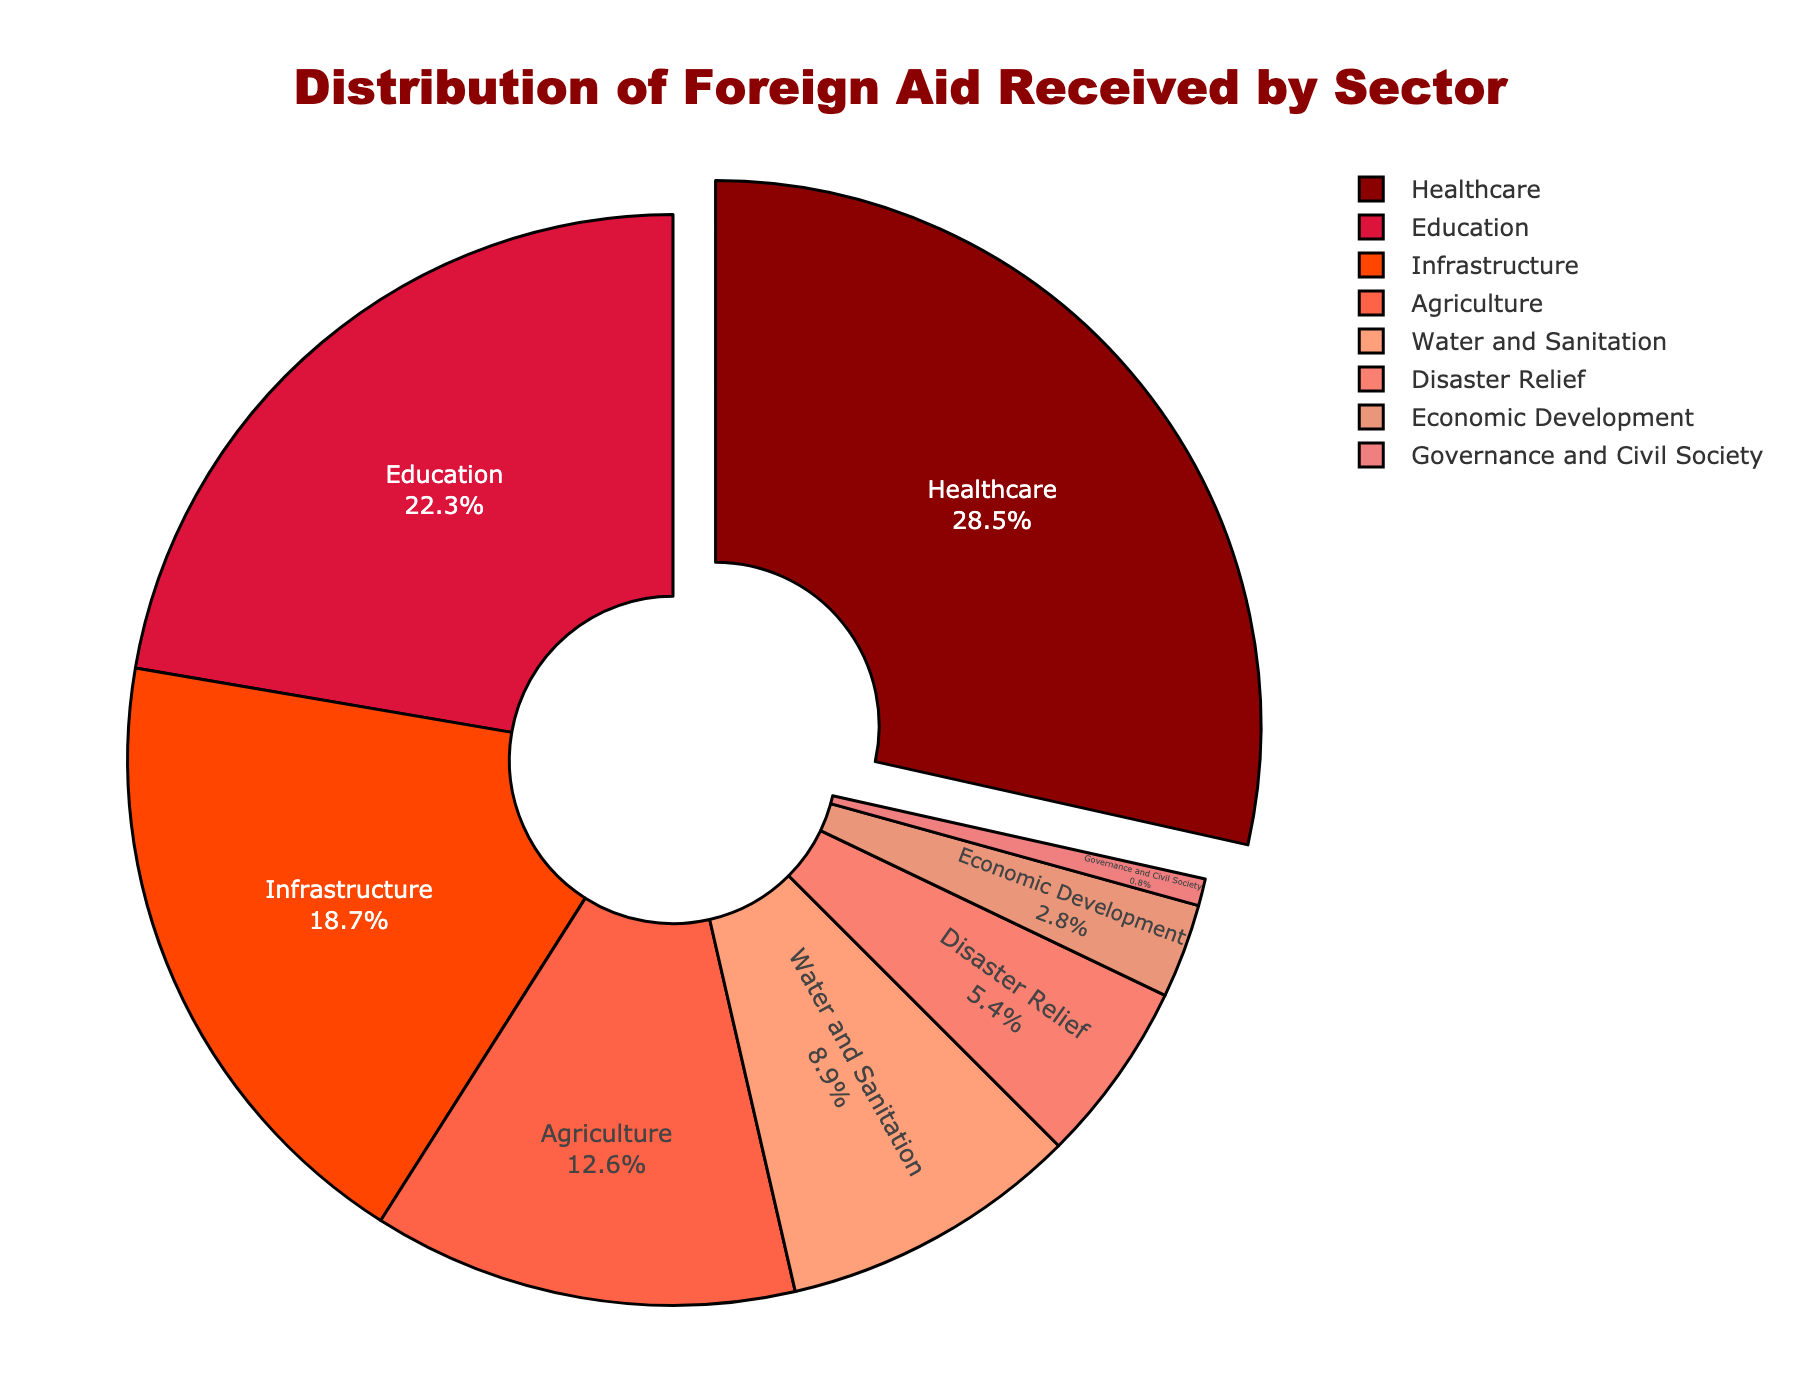What percentage of foreign aid is received by Healthcare? Healthcare receives 28.5% of the total foreign aid, as shown directly in the pie chart.
Answer: 28.5% Which sector receives the lowest percentage of foreign aid? Governance and Civil Society receives the smallest percentage of aid at 0.8%, as indicated in the chart.
Answer: Governance and Civil Society How much more aid does Healthcare receive compared to Economic Development? Healthcare receives 28.5%, while Economic Development receives 2.8%. The difference is 28.5% - 2.8% = 25.7%.
Answer: 25.7% Are Healthcare and Education sectors combined receiving more than 50% of the aid? Healthcare receives 28.5% and Education receives 22.3%. Combined, they receive 28.5% + 22.3% = 50.8%, which is more than 50%.
Answer: Yes What is the total percentage of aid received by Infrastructure and Agriculture sectors together? Infrastructure receives 18.7% and Agriculture receives 12.6%. Together, they receive 18.7% + 12.6% = 31.3%.
Answer: 31.3% Which sector receives more aid: Water and Sanitation or Disaster Relief? Water and Sanitation receives 8.9%, while Disaster Relief receives 5.4%. 8.9% is more than 5.4%.
Answer: Water and Sanitation What percentage of foreign aid is received by sectors excluding Healthcare and Education? Total for Healthcare and Education together is 28.5% + 22.3% = 50.8%. Excluding these sectors, the remaining sectors receive 100% - 50.8% = 49.2%.
Answer: 49.2% How much less aid does Governance and Civil Society receive compared to Agriculture? Governance and Civil Society receives 0.8%, while Agriculture receives 12.6%. The difference is 12.6% - 0.8% = 11.8%.
Answer: 11.8% Which color represents the sector that receives the highest percentage of foreign aid? The sector receiving the most aid is Healthcare, and it is represented by the darkest red color in the pie chart.
Answer: Darkest Red Is the sum of the percentages of Disaster Relief and Economic Development less than the percentage of Education? Disaster Relief receives 5.4% and Economic Development receives 2.8%. Combined, they receive 5.4% + 2.8% = 8.2%. Education receives 22.3%, which is greater than 8.2%.
Answer: Yes 